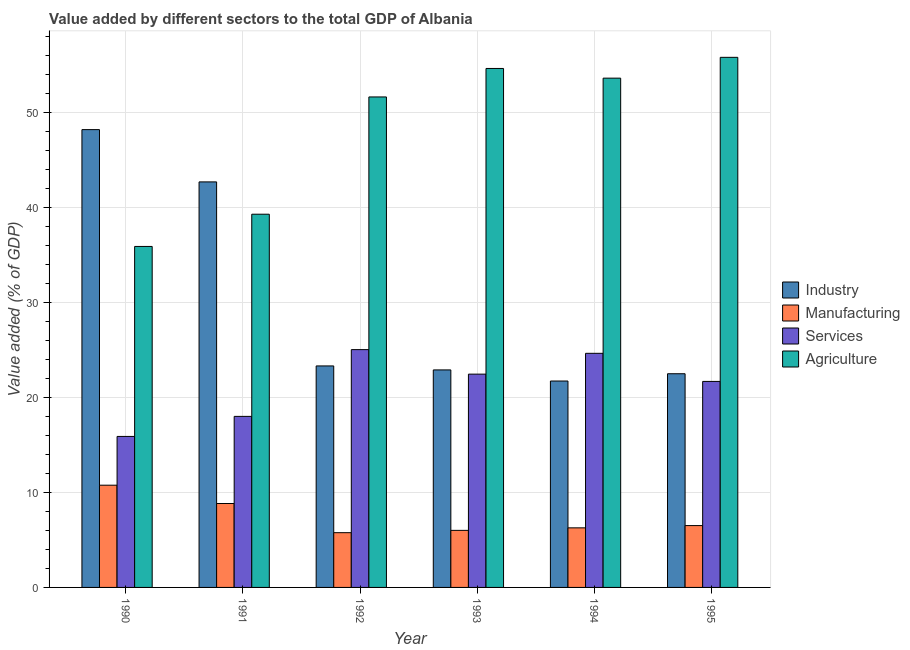Are the number of bars per tick equal to the number of legend labels?
Your answer should be very brief. Yes. How many bars are there on the 2nd tick from the left?
Keep it short and to the point. 4. In how many cases, is the number of bars for a given year not equal to the number of legend labels?
Keep it short and to the point. 0. What is the value added by industrial sector in 1993?
Provide a short and direct response. 22.9. Across all years, what is the maximum value added by services sector?
Keep it short and to the point. 25.04. Across all years, what is the minimum value added by industrial sector?
Your answer should be very brief. 21.73. In which year was the value added by agricultural sector maximum?
Provide a short and direct response. 1995. What is the total value added by services sector in the graph?
Your response must be concise. 127.74. What is the difference between the value added by industrial sector in 1990 and that in 1994?
Make the answer very short. 26.47. What is the difference between the value added by manufacturing sector in 1992 and the value added by industrial sector in 1991?
Your response must be concise. -3.07. What is the average value added by manufacturing sector per year?
Your response must be concise. 7.36. In the year 1995, what is the difference between the value added by manufacturing sector and value added by services sector?
Your answer should be very brief. 0. In how many years, is the value added by industrial sector greater than 36 %?
Ensure brevity in your answer.  2. What is the ratio of the value added by industrial sector in 1990 to that in 1993?
Your response must be concise. 2.1. Is the value added by manufacturing sector in 1991 less than that in 1993?
Your answer should be very brief. No. Is the difference between the value added by services sector in 1992 and 1993 greater than the difference between the value added by industrial sector in 1992 and 1993?
Keep it short and to the point. No. What is the difference between the highest and the second highest value added by manufacturing sector?
Give a very brief answer. 1.93. What is the difference between the highest and the lowest value added by agricultural sector?
Give a very brief answer. 19.91. Is the sum of the value added by services sector in 1990 and 1992 greater than the maximum value added by manufacturing sector across all years?
Your answer should be compact. Yes. What does the 3rd bar from the left in 1994 represents?
Provide a succinct answer. Services. What does the 4th bar from the right in 1993 represents?
Offer a very short reply. Industry. Is it the case that in every year, the sum of the value added by industrial sector and value added by manufacturing sector is greater than the value added by services sector?
Your answer should be compact. Yes. How many bars are there?
Your response must be concise. 24. How many years are there in the graph?
Keep it short and to the point. 6. What is the difference between two consecutive major ticks on the Y-axis?
Ensure brevity in your answer.  10. Does the graph contain any zero values?
Keep it short and to the point. No. Does the graph contain grids?
Offer a very short reply. Yes. Where does the legend appear in the graph?
Provide a short and direct response. Center right. How many legend labels are there?
Give a very brief answer. 4. How are the legend labels stacked?
Your answer should be compact. Vertical. What is the title of the graph?
Your answer should be very brief. Value added by different sectors to the total GDP of Albania. Does "Taxes on exports" appear as one of the legend labels in the graph?
Your answer should be compact. No. What is the label or title of the Y-axis?
Ensure brevity in your answer.  Value added (% of GDP). What is the Value added (% of GDP) in Industry in 1990?
Keep it short and to the point. 48.2. What is the Value added (% of GDP) in Manufacturing in 1990?
Provide a short and direct response. 10.76. What is the Value added (% of GDP) of Services in 1990?
Keep it short and to the point. 15.9. What is the Value added (% of GDP) of Agriculture in 1990?
Provide a succinct answer. 35.9. What is the Value added (% of GDP) of Industry in 1991?
Make the answer very short. 42.7. What is the Value added (% of GDP) of Manufacturing in 1991?
Your answer should be compact. 8.84. What is the Value added (% of GDP) of Services in 1991?
Your response must be concise. 18.01. What is the Value added (% of GDP) in Agriculture in 1991?
Ensure brevity in your answer.  39.3. What is the Value added (% of GDP) of Industry in 1992?
Your response must be concise. 23.32. What is the Value added (% of GDP) in Manufacturing in 1992?
Your answer should be very brief. 5.76. What is the Value added (% of GDP) of Services in 1992?
Your answer should be very brief. 25.04. What is the Value added (% of GDP) of Agriculture in 1992?
Your answer should be very brief. 51.64. What is the Value added (% of GDP) in Industry in 1993?
Offer a terse response. 22.9. What is the Value added (% of GDP) in Manufacturing in 1993?
Provide a succinct answer. 6.01. What is the Value added (% of GDP) in Services in 1993?
Offer a very short reply. 22.46. What is the Value added (% of GDP) in Agriculture in 1993?
Give a very brief answer. 54.64. What is the Value added (% of GDP) of Industry in 1994?
Ensure brevity in your answer.  21.73. What is the Value added (% of GDP) in Manufacturing in 1994?
Your response must be concise. 6.27. What is the Value added (% of GDP) in Services in 1994?
Offer a terse response. 24.65. What is the Value added (% of GDP) in Agriculture in 1994?
Your answer should be very brief. 53.62. What is the Value added (% of GDP) in Industry in 1995?
Give a very brief answer. 22.5. What is the Value added (% of GDP) of Manufacturing in 1995?
Offer a terse response. 6.51. What is the Value added (% of GDP) of Services in 1995?
Offer a very short reply. 21.69. What is the Value added (% of GDP) of Agriculture in 1995?
Your answer should be very brief. 55.81. Across all years, what is the maximum Value added (% of GDP) of Industry?
Offer a very short reply. 48.2. Across all years, what is the maximum Value added (% of GDP) in Manufacturing?
Your answer should be compact. 10.76. Across all years, what is the maximum Value added (% of GDP) in Services?
Your answer should be compact. 25.04. Across all years, what is the maximum Value added (% of GDP) of Agriculture?
Keep it short and to the point. 55.81. Across all years, what is the minimum Value added (% of GDP) of Industry?
Give a very brief answer. 21.73. Across all years, what is the minimum Value added (% of GDP) in Manufacturing?
Provide a short and direct response. 5.76. Across all years, what is the minimum Value added (% of GDP) of Services?
Your answer should be very brief. 15.9. Across all years, what is the minimum Value added (% of GDP) of Agriculture?
Provide a succinct answer. 35.9. What is the total Value added (% of GDP) in Industry in the graph?
Ensure brevity in your answer.  181.35. What is the total Value added (% of GDP) of Manufacturing in the graph?
Ensure brevity in your answer.  44.15. What is the total Value added (% of GDP) of Services in the graph?
Your response must be concise. 127.74. What is the total Value added (% of GDP) in Agriculture in the graph?
Offer a very short reply. 290.91. What is the difference between the Value added (% of GDP) of Industry in 1990 and that in 1991?
Your answer should be very brief. 5.5. What is the difference between the Value added (% of GDP) in Manufacturing in 1990 and that in 1991?
Make the answer very short. 1.93. What is the difference between the Value added (% of GDP) in Services in 1990 and that in 1991?
Give a very brief answer. -2.11. What is the difference between the Value added (% of GDP) in Agriculture in 1990 and that in 1991?
Keep it short and to the point. -3.39. What is the difference between the Value added (% of GDP) in Industry in 1990 and that in 1992?
Offer a very short reply. 24.88. What is the difference between the Value added (% of GDP) in Manufacturing in 1990 and that in 1992?
Give a very brief answer. 5. What is the difference between the Value added (% of GDP) of Services in 1990 and that in 1992?
Provide a short and direct response. -9.14. What is the difference between the Value added (% of GDP) of Agriculture in 1990 and that in 1992?
Keep it short and to the point. -15.74. What is the difference between the Value added (% of GDP) of Industry in 1990 and that in 1993?
Keep it short and to the point. 25.3. What is the difference between the Value added (% of GDP) in Manufacturing in 1990 and that in 1993?
Provide a succinct answer. 4.76. What is the difference between the Value added (% of GDP) in Services in 1990 and that in 1993?
Provide a short and direct response. -6.56. What is the difference between the Value added (% of GDP) of Agriculture in 1990 and that in 1993?
Your response must be concise. -18.74. What is the difference between the Value added (% of GDP) in Industry in 1990 and that in 1994?
Give a very brief answer. 26.47. What is the difference between the Value added (% of GDP) in Manufacturing in 1990 and that in 1994?
Provide a short and direct response. 4.49. What is the difference between the Value added (% of GDP) in Services in 1990 and that in 1994?
Offer a very short reply. -8.75. What is the difference between the Value added (% of GDP) of Agriculture in 1990 and that in 1994?
Give a very brief answer. -17.72. What is the difference between the Value added (% of GDP) of Industry in 1990 and that in 1995?
Ensure brevity in your answer.  25.7. What is the difference between the Value added (% of GDP) in Manufacturing in 1990 and that in 1995?
Give a very brief answer. 4.25. What is the difference between the Value added (% of GDP) of Services in 1990 and that in 1995?
Provide a short and direct response. -5.79. What is the difference between the Value added (% of GDP) in Agriculture in 1990 and that in 1995?
Provide a succinct answer. -19.91. What is the difference between the Value added (% of GDP) of Industry in 1991 and that in 1992?
Give a very brief answer. 19.38. What is the difference between the Value added (% of GDP) in Manufacturing in 1991 and that in 1992?
Your answer should be very brief. 3.07. What is the difference between the Value added (% of GDP) in Services in 1991 and that in 1992?
Give a very brief answer. -7.03. What is the difference between the Value added (% of GDP) in Agriculture in 1991 and that in 1992?
Offer a terse response. -12.35. What is the difference between the Value added (% of GDP) of Industry in 1991 and that in 1993?
Keep it short and to the point. 19.8. What is the difference between the Value added (% of GDP) in Manufacturing in 1991 and that in 1993?
Provide a short and direct response. 2.83. What is the difference between the Value added (% of GDP) in Services in 1991 and that in 1993?
Ensure brevity in your answer.  -4.45. What is the difference between the Value added (% of GDP) in Agriculture in 1991 and that in 1993?
Your answer should be compact. -15.35. What is the difference between the Value added (% of GDP) in Industry in 1991 and that in 1994?
Provide a succinct answer. 20.97. What is the difference between the Value added (% of GDP) in Manufacturing in 1991 and that in 1994?
Your answer should be compact. 2.56. What is the difference between the Value added (% of GDP) of Services in 1991 and that in 1994?
Your response must be concise. -6.64. What is the difference between the Value added (% of GDP) of Agriculture in 1991 and that in 1994?
Provide a short and direct response. -14.33. What is the difference between the Value added (% of GDP) in Industry in 1991 and that in 1995?
Your response must be concise. 20.2. What is the difference between the Value added (% of GDP) of Manufacturing in 1991 and that in 1995?
Provide a succinct answer. 2.33. What is the difference between the Value added (% of GDP) in Services in 1991 and that in 1995?
Provide a short and direct response. -3.68. What is the difference between the Value added (% of GDP) of Agriculture in 1991 and that in 1995?
Ensure brevity in your answer.  -16.52. What is the difference between the Value added (% of GDP) in Industry in 1992 and that in 1993?
Your response must be concise. 0.42. What is the difference between the Value added (% of GDP) in Manufacturing in 1992 and that in 1993?
Your response must be concise. -0.24. What is the difference between the Value added (% of GDP) in Services in 1992 and that in 1993?
Offer a terse response. 2.58. What is the difference between the Value added (% of GDP) in Agriculture in 1992 and that in 1993?
Offer a very short reply. -3. What is the difference between the Value added (% of GDP) of Industry in 1992 and that in 1994?
Offer a very short reply. 1.59. What is the difference between the Value added (% of GDP) of Manufacturing in 1992 and that in 1994?
Offer a very short reply. -0.51. What is the difference between the Value added (% of GDP) of Services in 1992 and that in 1994?
Offer a very short reply. 0.39. What is the difference between the Value added (% of GDP) of Agriculture in 1992 and that in 1994?
Make the answer very short. -1.98. What is the difference between the Value added (% of GDP) of Industry in 1992 and that in 1995?
Provide a succinct answer. 0.82. What is the difference between the Value added (% of GDP) in Manufacturing in 1992 and that in 1995?
Offer a very short reply. -0.75. What is the difference between the Value added (% of GDP) in Services in 1992 and that in 1995?
Ensure brevity in your answer.  3.35. What is the difference between the Value added (% of GDP) of Agriculture in 1992 and that in 1995?
Keep it short and to the point. -4.17. What is the difference between the Value added (% of GDP) in Industry in 1993 and that in 1994?
Ensure brevity in your answer.  1.17. What is the difference between the Value added (% of GDP) in Manufacturing in 1993 and that in 1994?
Keep it short and to the point. -0.27. What is the difference between the Value added (% of GDP) in Services in 1993 and that in 1994?
Make the answer very short. -2.19. What is the difference between the Value added (% of GDP) in Agriculture in 1993 and that in 1994?
Offer a terse response. 1.02. What is the difference between the Value added (% of GDP) in Industry in 1993 and that in 1995?
Your answer should be compact. 0.4. What is the difference between the Value added (% of GDP) in Manufacturing in 1993 and that in 1995?
Ensure brevity in your answer.  -0.5. What is the difference between the Value added (% of GDP) of Services in 1993 and that in 1995?
Give a very brief answer. 0.77. What is the difference between the Value added (% of GDP) in Agriculture in 1993 and that in 1995?
Give a very brief answer. -1.17. What is the difference between the Value added (% of GDP) of Industry in 1994 and that in 1995?
Ensure brevity in your answer.  -0.77. What is the difference between the Value added (% of GDP) in Manufacturing in 1994 and that in 1995?
Offer a very short reply. -0.24. What is the difference between the Value added (% of GDP) in Services in 1994 and that in 1995?
Your answer should be very brief. 2.96. What is the difference between the Value added (% of GDP) in Agriculture in 1994 and that in 1995?
Your answer should be very brief. -2.19. What is the difference between the Value added (% of GDP) in Industry in 1990 and the Value added (% of GDP) in Manufacturing in 1991?
Your answer should be very brief. 39.36. What is the difference between the Value added (% of GDP) in Industry in 1990 and the Value added (% of GDP) in Services in 1991?
Offer a terse response. 30.19. What is the difference between the Value added (% of GDP) of Industry in 1990 and the Value added (% of GDP) of Agriculture in 1991?
Keep it short and to the point. 8.91. What is the difference between the Value added (% of GDP) in Manufacturing in 1990 and the Value added (% of GDP) in Services in 1991?
Provide a short and direct response. -7.24. What is the difference between the Value added (% of GDP) of Manufacturing in 1990 and the Value added (% of GDP) of Agriculture in 1991?
Your answer should be very brief. -28.53. What is the difference between the Value added (% of GDP) of Services in 1990 and the Value added (% of GDP) of Agriculture in 1991?
Provide a short and direct response. -23.4. What is the difference between the Value added (% of GDP) of Industry in 1990 and the Value added (% of GDP) of Manufacturing in 1992?
Give a very brief answer. 42.44. What is the difference between the Value added (% of GDP) in Industry in 1990 and the Value added (% of GDP) in Services in 1992?
Make the answer very short. 23.16. What is the difference between the Value added (% of GDP) in Industry in 1990 and the Value added (% of GDP) in Agriculture in 1992?
Offer a very short reply. -3.44. What is the difference between the Value added (% of GDP) in Manufacturing in 1990 and the Value added (% of GDP) in Services in 1992?
Keep it short and to the point. -14.27. What is the difference between the Value added (% of GDP) in Manufacturing in 1990 and the Value added (% of GDP) in Agriculture in 1992?
Give a very brief answer. -40.88. What is the difference between the Value added (% of GDP) in Services in 1990 and the Value added (% of GDP) in Agriculture in 1992?
Your response must be concise. -35.74. What is the difference between the Value added (% of GDP) of Industry in 1990 and the Value added (% of GDP) of Manufacturing in 1993?
Ensure brevity in your answer.  42.19. What is the difference between the Value added (% of GDP) of Industry in 1990 and the Value added (% of GDP) of Services in 1993?
Offer a terse response. 25.74. What is the difference between the Value added (% of GDP) in Industry in 1990 and the Value added (% of GDP) in Agriculture in 1993?
Ensure brevity in your answer.  -6.44. What is the difference between the Value added (% of GDP) of Manufacturing in 1990 and the Value added (% of GDP) of Services in 1993?
Offer a terse response. -11.69. What is the difference between the Value added (% of GDP) in Manufacturing in 1990 and the Value added (% of GDP) in Agriculture in 1993?
Your answer should be very brief. -43.88. What is the difference between the Value added (% of GDP) in Services in 1990 and the Value added (% of GDP) in Agriculture in 1993?
Offer a very short reply. -38.74. What is the difference between the Value added (% of GDP) of Industry in 1990 and the Value added (% of GDP) of Manufacturing in 1994?
Provide a short and direct response. 41.93. What is the difference between the Value added (% of GDP) of Industry in 1990 and the Value added (% of GDP) of Services in 1994?
Offer a terse response. 23.55. What is the difference between the Value added (% of GDP) of Industry in 1990 and the Value added (% of GDP) of Agriculture in 1994?
Your answer should be compact. -5.42. What is the difference between the Value added (% of GDP) in Manufacturing in 1990 and the Value added (% of GDP) in Services in 1994?
Your answer should be compact. -13.88. What is the difference between the Value added (% of GDP) of Manufacturing in 1990 and the Value added (% of GDP) of Agriculture in 1994?
Give a very brief answer. -42.86. What is the difference between the Value added (% of GDP) of Services in 1990 and the Value added (% of GDP) of Agriculture in 1994?
Offer a very short reply. -37.72. What is the difference between the Value added (% of GDP) in Industry in 1990 and the Value added (% of GDP) in Manufacturing in 1995?
Ensure brevity in your answer.  41.69. What is the difference between the Value added (% of GDP) in Industry in 1990 and the Value added (% of GDP) in Services in 1995?
Give a very brief answer. 26.51. What is the difference between the Value added (% of GDP) in Industry in 1990 and the Value added (% of GDP) in Agriculture in 1995?
Make the answer very short. -7.61. What is the difference between the Value added (% of GDP) in Manufacturing in 1990 and the Value added (% of GDP) in Services in 1995?
Make the answer very short. -10.93. What is the difference between the Value added (% of GDP) in Manufacturing in 1990 and the Value added (% of GDP) in Agriculture in 1995?
Keep it short and to the point. -45.05. What is the difference between the Value added (% of GDP) of Services in 1990 and the Value added (% of GDP) of Agriculture in 1995?
Your answer should be compact. -39.91. What is the difference between the Value added (% of GDP) of Industry in 1991 and the Value added (% of GDP) of Manufacturing in 1992?
Offer a very short reply. 36.93. What is the difference between the Value added (% of GDP) of Industry in 1991 and the Value added (% of GDP) of Services in 1992?
Your answer should be very brief. 17.66. What is the difference between the Value added (% of GDP) in Industry in 1991 and the Value added (% of GDP) in Agriculture in 1992?
Provide a short and direct response. -8.95. What is the difference between the Value added (% of GDP) in Manufacturing in 1991 and the Value added (% of GDP) in Services in 1992?
Give a very brief answer. -16.2. What is the difference between the Value added (% of GDP) in Manufacturing in 1991 and the Value added (% of GDP) in Agriculture in 1992?
Your answer should be very brief. -42.81. What is the difference between the Value added (% of GDP) in Services in 1991 and the Value added (% of GDP) in Agriculture in 1992?
Provide a succinct answer. -33.63. What is the difference between the Value added (% of GDP) in Industry in 1991 and the Value added (% of GDP) in Manufacturing in 1993?
Your response must be concise. 36.69. What is the difference between the Value added (% of GDP) in Industry in 1991 and the Value added (% of GDP) in Services in 1993?
Give a very brief answer. 20.24. What is the difference between the Value added (% of GDP) of Industry in 1991 and the Value added (% of GDP) of Agriculture in 1993?
Your response must be concise. -11.94. What is the difference between the Value added (% of GDP) in Manufacturing in 1991 and the Value added (% of GDP) in Services in 1993?
Ensure brevity in your answer.  -13.62. What is the difference between the Value added (% of GDP) of Manufacturing in 1991 and the Value added (% of GDP) of Agriculture in 1993?
Keep it short and to the point. -45.81. What is the difference between the Value added (% of GDP) in Services in 1991 and the Value added (% of GDP) in Agriculture in 1993?
Give a very brief answer. -36.63. What is the difference between the Value added (% of GDP) of Industry in 1991 and the Value added (% of GDP) of Manufacturing in 1994?
Give a very brief answer. 36.42. What is the difference between the Value added (% of GDP) of Industry in 1991 and the Value added (% of GDP) of Services in 1994?
Offer a very short reply. 18.05. What is the difference between the Value added (% of GDP) of Industry in 1991 and the Value added (% of GDP) of Agriculture in 1994?
Give a very brief answer. -10.92. What is the difference between the Value added (% of GDP) of Manufacturing in 1991 and the Value added (% of GDP) of Services in 1994?
Make the answer very short. -15.81. What is the difference between the Value added (% of GDP) of Manufacturing in 1991 and the Value added (% of GDP) of Agriculture in 1994?
Offer a terse response. -44.79. What is the difference between the Value added (% of GDP) in Services in 1991 and the Value added (% of GDP) in Agriculture in 1994?
Offer a terse response. -35.61. What is the difference between the Value added (% of GDP) of Industry in 1991 and the Value added (% of GDP) of Manufacturing in 1995?
Give a very brief answer. 36.19. What is the difference between the Value added (% of GDP) in Industry in 1991 and the Value added (% of GDP) in Services in 1995?
Provide a short and direct response. 21.01. What is the difference between the Value added (% of GDP) of Industry in 1991 and the Value added (% of GDP) of Agriculture in 1995?
Ensure brevity in your answer.  -13.12. What is the difference between the Value added (% of GDP) of Manufacturing in 1991 and the Value added (% of GDP) of Services in 1995?
Your answer should be compact. -12.85. What is the difference between the Value added (% of GDP) of Manufacturing in 1991 and the Value added (% of GDP) of Agriculture in 1995?
Offer a very short reply. -46.98. What is the difference between the Value added (% of GDP) of Services in 1991 and the Value added (% of GDP) of Agriculture in 1995?
Your response must be concise. -37.8. What is the difference between the Value added (% of GDP) of Industry in 1992 and the Value added (% of GDP) of Manufacturing in 1993?
Your response must be concise. 17.31. What is the difference between the Value added (% of GDP) in Industry in 1992 and the Value added (% of GDP) in Services in 1993?
Offer a terse response. 0.86. What is the difference between the Value added (% of GDP) in Industry in 1992 and the Value added (% of GDP) in Agriculture in 1993?
Your response must be concise. -31.32. What is the difference between the Value added (% of GDP) in Manufacturing in 1992 and the Value added (% of GDP) in Services in 1993?
Your response must be concise. -16.69. What is the difference between the Value added (% of GDP) in Manufacturing in 1992 and the Value added (% of GDP) in Agriculture in 1993?
Your answer should be very brief. -48.88. What is the difference between the Value added (% of GDP) in Services in 1992 and the Value added (% of GDP) in Agriculture in 1993?
Make the answer very short. -29.6. What is the difference between the Value added (% of GDP) of Industry in 1992 and the Value added (% of GDP) of Manufacturing in 1994?
Your response must be concise. 17.05. What is the difference between the Value added (% of GDP) in Industry in 1992 and the Value added (% of GDP) in Services in 1994?
Your response must be concise. -1.33. What is the difference between the Value added (% of GDP) of Industry in 1992 and the Value added (% of GDP) of Agriculture in 1994?
Your response must be concise. -30.3. What is the difference between the Value added (% of GDP) in Manufacturing in 1992 and the Value added (% of GDP) in Services in 1994?
Provide a short and direct response. -18.88. What is the difference between the Value added (% of GDP) of Manufacturing in 1992 and the Value added (% of GDP) of Agriculture in 1994?
Provide a succinct answer. -47.86. What is the difference between the Value added (% of GDP) of Services in 1992 and the Value added (% of GDP) of Agriculture in 1994?
Make the answer very short. -28.58. What is the difference between the Value added (% of GDP) in Industry in 1992 and the Value added (% of GDP) in Manufacturing in 1995?
Keep it short and to the point. 16.81. What is the difference between the Value added (% of GDP) of Industry in 1992 and the Value added (% of GDP) of Services in 1995?
Ensure brevity in your answer.  1.63. What is the difference between the Value added (% of GDP) in Industry in 1992 and the Value added (% of GDP) in Agriculture in 1995?
Your response must be concise. -32.49. What is the difference between the Value added (% of GDP) in Manufacturing in 1992 and the Value added (% of GDP) in Services in 1995?
Ensure brevity in your answer.  -15.93. What is the difference between the Value added (% of GDP) of Manufacturing in 1992 and the Value added (% of GDP) of Agriculture in 1995?
Provide a short and direct response. -50.05. What is the difference between the Value added (% of GDP) in Services in 1992 and the Value added (% of GDP) in Agriculture in 1995?
Give a very brief answer. -30.77. What is the difference between the Value added (% of GDP) in Industry in 1993 and the Value added (% of GDP) in Manufacturing in 1994?
Your answer should be compact. 16.63. What is the difference between the Value added (% of GDP) of Industry in 1993 and the Value added (% of GDP) of Services in 1994?
Keep it short and to the point. -1.75. What is the difference between the Value added (% of GDP) of Industry in 1993 and the Value added (% of GDP) of Agriculture in 1994?
Keep it short and to the point. -30.72. What is the difference between the Value added (% of GDP) of Manufacturing in 1993 and the Value added (% of GDP) of Services in 1994?
Offer a very short reply. -18.64. What is the difference between the Value added (% of GDP) of Manufacturing in 1993 and the Value added (% of GDP) of Agriculture in 1994?
Make the answer very short. -47.61. What is the difference between the Value added (% of GDP) in Services in 1993 and the Value added (% of GDP) in Agriculture in 1994?
Provide a short and direct response. -31.16. What is the difference between the Value added (% of GDP) of Industry in 1993 and the Value added (% of GDP) of Manufacturing in 1995?
Keep it short and to the point. 16.39. What is the difference between the Value added (% of GDP) in Industry in 1993 and the Value added (% of GDP) in Services in 1995?
Your answer should be compact. 1.21. What is the difference between the Value added (% of GDP) in Industry in 1993 and the Value added (% of GDP) in Agriculture in 1995?
Offer a very short reply. -32.91. What is the difference between the Value added (% of GDP) of Manufacturing in 1993 and the Value added (% of GDP) of Services in 1995?
Offer a terse response. -15.68. What is the difference between the Value added (% of GDP) in Manufacturing in 1993 and the Value added (% of GDP) in Agriculture in 1995?
Offer a very short reply. -49.81. What is the difference between the Value added (% of GDP) of Services in 1993 and the Value added (% of GDP) of Agriculture in 1995?
Keep it short and to the point. -33.35. What is the difference between the Value added (% of GDP) in Industry in 1994 and the Value added (% of GDP) in Manufacturing in 1995?
Keep it short and to the point. 15.22. What is the difference between the Value added (% of GDP) in Industry in 1994 and the Value added (% of GDP) in Services in 1995?
Ensure brevity in your answer.  0.04. What is the difference between the Value added (% of GDP) in Industry in 1994 and the Value added (% of GDP) in Agriculture in 1995?
Ensure brevity in your answer.  -34.08. What is the difference between the Value added (% of GDP) in Manufacturing in 1994 and the Value added (% of GDP) in Services in 1995?
Your response must be concise. -15.42. What is the difference between the Value added (% of GDP) in Manufacturing in 1994 and the Value added (% of GDP) in Agriculture in 1995?
Ensure brevity in your answer.  -49.54. What is the difference between the Value added (% of GDP) of Services in 1994 and the Value added (% of GDP) of Agriculture in 1995?
Provide a short and direct response. -31.16. What is the average Value added (% of GDP) in Industry per year?
Give a very brief answer. 30.22. What is the average Value added (% of GDP) of Manufacturing per year?
Offer a very short reply. 7.36. What is the average Value added (% of GDP) in Services per year?
Give a very brief answer. 21.29. What is the average Value added (% of GDP) in Agriculture per year?
Make the answer very short. 48.49. In the year 1990, what is the difference between the Value added (% of GDP) of Industry and Value added (% of GDP) of Manufacturing?
Ensure brevity in your answer.  37.44. In the year 1990, what is the difference between the Value added (% of GDP) of Industry and Value added (% of GDP) of Services?
Your answer should be compact. 32.3. In the year 1990, what is the difference between the Value added (% of GDP) in Manufacturing and Value added (% of GDP) in Services?
Your answer should be very brief. -5.13. In the year 1990, what is the difference between the Value added (% of GDP) of Manufacturing and Value added (% of GDP) of Agriculture?
Your response must be concise. -25.14. In the year 1990, what is the difference between the Value added (% of GDP) of Services and Value added (% of GDP) of Agriculture?
Give a very brief answer. -20. In the year 1991, what is the difference between the Value added (% of GDP) in Industry and Value added (% of GDP) in Manufacturing?
Your answer should be compact. 33.86. In the year 1991, what is the difference between the Value added (% of GDP) of Industry and Value added (% of GDP) of Services?
Provide a succinct answer. 24.69. In the year 1991, what is the difference between the Value added (% of GDP) of Industry and Value added (% of GDP) of Agriculture?
Your answer should be compact. 3.4. In the year 1991, what is the difference between the Value added (% of GDP) in Manufacturing and Value added (% of GDP) in Services?
Keep it short and to the point. -9.17. In the year 1991, what is the difference between the Value added (% of GDP) in Manufacturing and Value added (% of GDP) in Agriculture?
Offer a very short reply. -30.46. In the year 1991, what is the difference between the Value added (% of GDP) in Services and Value added (% of GDP) in Agriculture?
Provide a short and direct response. -21.29. In the year 1992, what is the difference between the Value added (% of GDP) in Industry and Value added (% of GDP) in Manufacturing?
Keep it short and to the point. 17.56. In the year 1992, what is the difference between the Value added (% of GDP) in Industry and Value added (% of GDP) in Services?
Ensure brevity in your answer.  -1.72. In the year 1992, what is the difference between the Value added (% of GDP) of Industry and Value added (% of GDP) of Agriculture?
Provide a short and direct response. -28.32. In the year 1992, what is the difference between the Value added (% of GDP) of Manufacturing and Value added (% of GDP) of Services?
Provide a succinct answer. -19.27. In the year 1992, what is the difference between the Value added (% of GDP) in Manufacturing and Value added (% of GDP) in Agriculture?
Your answer should be compact. -45.88. In the year 1992, what is the difference between the Value added (% of GDP) in Services and Value added (% of GDP) in Agriculture?
Ensure brevity in your answer.  -26.6. In the year 1993, what is the difference between the Value added (% of GDP) in Industry and Value added (% of GDP) in Manufacturing?
Your answer should be very brief. 16.89. In the year 1993, what is the difference between the Value added (% of GDP) in Industry and Value added (% of GDP) in Services?
Your answer should be compact. 0.44. In the year 1993, what is the difference between the Value added (% of GDP) of Industry and Value added (% of GDP) of Agriculture?
Provide a short and direct response. -31.74. In the year 1993, what is the difference between the Value added (% of GDP) in Manufacturing and Value added (% of GDP) in Services?
Offer a terse response. -16.45. In the year 1993, what is the difference between the Value added (% of GDP) of Manufacturing and Value added (% of GDP) of Agriculture?
Your answer should be compact. -48.63. In the year 1993, what is the difference between the Value added (% of GDP) in Services and Value added (% of GDP) in Agriculture?
Offer a very short reply. -32.18. In the year 1994, what is the difference between the Value added (% of GDP) in Industry and Value added (% of GDP) in Manufacturing?
Your answer should be compact. 15.46. In the year 1994, what is the difference between the Value added (% of GDP) of Industry and Value added (% of GDP) of Services?
Provide a short and direct response. -2.92. In the year 1994, what is the difference between the Value added (% of GDP) in Industry and Value added (% of GDP) in Agriculture?
Offer a very short reply. -31.89. In the year 1994, what is the difference between the Value added (% of GDP) in Manufacturing and Value added (% of GDP) in Services?
Your response must be concise. -18.38. In the year 1994, what is the difference between the Value added (% of GDP) in Manufacturing and Value added (% of GDP) in Agriculture?
Offer a terse response. -47.35. In the year 1994, what is the difference between the Value added (% of GDP) of Services and Value added (% of GDP) of Agriculture?
Keep it short and to the point. -28.97. In the year 1995, what is the difference between the Value added (% of GDP) of Industry and Value added (% of GDP) of Manufacturing?
Make the answer very short. 15.99. In the year 1995, what is the difference between the Value added (% of GDP) in Industry and Value added (% of GDP) in Services?
Give a very brief answer. 0.81. In the year 1995, what is the difference between the Value added (% of GDP) in Industry and Value added (% of GDP) in Agriculture?
Offer a terse response. -33.31. In the year 1995, what is the difference between the Value added (% of GDP) of Manufacturing and Value added (% of GDP) of Services?
Offer a very short reply. -15.18. In the year 1995, what is the difference between the Value added (% of GDP) in Manufacturing and Value added (% of GDP) in Agriculture?
Your answer should be very brief. -49.3. In the year 1995, what is the difference between the Value added (% of GDP) in Services and Value added (% of GDP) in Agriculture?
Make the answer very short. -34.12. What is the ratio of the Value added (% of GDP) of Industry in 1990 to that in 1991?
Offer a very short reply. 1.13. What is the ratio of the Value added (% of GDP) of Manufacturing in 1990 to that in 1991?
Your response must be concise. 1.22. What is the ratio of the Value added (% of GDP) of Services in 1990 to that in 1991?
Your response must be concise. 0.88. What is the ratio of the Value added (% of GDP) in Agriculture in 1990 to that in 1991?
Provide a short and direct response. 0.91. What is the ratio of the Value added (% of GDP) in Industry in 1990 to that in 1992?
Keep it short and to the point. 2.07. What is the ratio of the Value added (% of GDP) in Manufacturing in 1990 to that in 1992?
Your answer should be very brief. 1.87. What is the ratio of the Value added (% of GDP) of Services in 1990 to that in 1992?
Offer a terse response. 0.64. What is the ratio of the Value added (% of GDP) in Agriculture in 1990 to that in 1992?
Offer a very short reply. 0.7. What is the ratio of the Value added (% of GDP) in Industry in 1990 to that in 1993?
Ensure brevity in your answer.  2.1. What is the ratio of the Value added (% of GDP) of Manufacturing in 1990 to that in 1993?
Provide a short and direct response. 1.79. What is the ratio of the Value added (% of GDP) of Services in 1990 to that in 1993?
Ensure brevity in your answer.  0.71. What is the ratio of the Value added (% of GDP) in Agriculture in 1990 to that in 1993?
Provide a short and direct response. 0.66. What is the ratio of the Value added (% of GDP) in Industry in 1990 to that in 1994?
Your response must be concise. 2.22. What is the ratio of the Value added (% of GDP) of Manufacturing in 1990 to that in 1994?
Give a very brief answer. 1.72. What is the ratio of the Value added (% of GDP) in Services in 1990 to that in 1994?
Your answer should be very brief. 0.65. What is the ratio of the Value added (% of GDP) of Agriculture in 1990 to that in 1994?
Offer a very short reply. 0.67. What is the ratio of the Value added (% of GDP) in Industry in 1990 to that in 1995?
Offer a terse response. 2.14. What is the ratio of the Value added (% of GDP) in Manufacturing in 1990 to that in 1995?
Keep it short and to the point. 1.65. What is the ratio of the Value added (% of GDP) in Services in 1990 to that in 1995?
Your response must be concise. 0.73. What is the ratio of the Value added (% of GDP) of Agriculture in 1990 to that in 1995?
Offer a very short reply. 0.64. What is the ratio of the Value added (% of GDP) of Industry in 1991 to that in 1992?
Make the answer very short. 1.83. What is the ratio of the Value added (% of GDP) of Manufacturing in 1991 to that in 1992?
Keep it short and to the point. 1.53. What is the ratio of the Value added (% of GDP) in Services in 1991 to that in 1992?
Provide a succinct answer. 0.72. What is the ratio of the Value added (% of GDP) in Agriculture in 1991 to that in 1992?
Make the answer very short. 0.76. What is the ratio of the Value added (% of GDP) of Industry in 1991 to that in 1993?
Your response must be concise. 1.86. What is the ratio of the Value added (% of GDP) in Manufacturing in 1991 to that in 1993?
Provide a short and direct response. 1.47. What is the ratio of the Value added (% of GDP) in Services in 1991 to that in 1993?
Your answer should be very brief. 0.8. What is the ratio of the Value added (% of GDP) in Agriculture in 1991 to that in 1993?
Offer a terse response. 0.72. What is the ratio of the Value added (% of GDP) in Industry in 1991 to that in 1994?
Your answer should be compact. 1.96. What is the ratio of the Value added (% of GDP) of Manufacturing in 1991 to that in 1994?
Give a very brief answer. 1.41. What is the ratio of the Value added (% of GDP) of Services in 1991 to that in 1994?
Offer a terse response. 0.73. What is the ratio of the Value added (% of GDP) in Agriculture in 1991 to that in 1994?
Ensure brevity in your answer.  0.73. What is the ratio of the Value added (% of GDP) in Industry in 1991 to that in 1995?
Offer a very short reply. 1.9. What is the ratio of the Value added (% of GDP) in Manufacturing in 1991 to that in 1995?
Offer a terse response. 1.36. What is the ratio of the Value added (% of GDP) in Services in 1991 to that in 1995?
Offer a terse response. 0.83. What is the ratio of the Value added (% of GDP) of Agriculture in 1991 to that in 1995?
Ensure brevity in your answer.  0.7. What is the ratio of the Value added (% of GDP) in Industry in 1992 to that in 1993?
Offer a very short reply. 1.02. What is the ratio of the Value added (% of GDP) of Manufacturing in 1992 to that in 1993?
Your response must be concise. 0.96. What is the ratio of the Value added (% of GDP) in Services in 1992 to that in 1993?
Your answer should be very brief. 1.11. What is the ratio of the Value added (% of GDP) of Agriculture in 1992 to that in 1993?
Give a very brief answer. 0.95. What is the ratio of the Value added (% of GDP) of Industry in 1992 to that in 1994?
Make the answer very short. 1.07. What is the ratio of the Value added (% of GDP) in Manufacturing in 1992 to that in 1994?
Make the answer very short. 0.92. What is the ratio of the Value added (% of GDP) of Services in 1992 to that in 1994?
Provide a succinct answer. 1.02. What is the ratio of the Value added (% of GDP) of Agriculture in 1992 to that in 1994?
Offer a terse response. 0.96. What is the ratio of the Value added (% of GDP) in Industry in 1992 to that in 1995?
Make the answer very short. 1.04. What is the ratio of the Value added (% of GDP) of Manufacturing in 1992 to that in 1995?
Provide a succinct answer. 0.89. What is the ratio of the Value added (% of GDP) of Services in 1992 to that in 1995?
Your answer should be compact. 1.15. What is the ratio of the Value added (% of GDP) in Agriculture in 1992 to that in 1995?
Give a very brief answer. 0.93. What is the ratio of the Value added (% of GDP) of Industry in 1993 to that in 1994?
Make the answer very short. 1.05. What is the ratio of the Value added (% of GDP) of Manufacturing in 1993 to that in 1994?
Give a very brief answer. 0.96. What is the ratio of the Value added (% of GDP) in Services in 1993 to that in 1994?
Make the answer very short. 0.91. What is the ratio of the Value added (% of GDP) in Agriculture in 1993 to that in 1994?
Provide a succinct answer. 1.02. What is the ratio of the Value added (% of GDP) in Industry in 1993 to that in 1995?
Your answer should be very brief. 1.02. What is the ratio of the Value added (% of GDP) of Manufacturing in 1993 to that in 1995?
Offer a terse response. 0.92. What is the ratio of the Value added (% of GDP) of Services in 1993 to that in 1995?
Your answer should be very brief. 1.04. What is the ratio of the Value added (% of GDP) in Agriculture in 1993 to that in 1995?
Your answer should be very brief. 0.98. What is the ratio of the Value added (% of GDP) in Industry in 1994 to that in 1995?
Your response must be concise. 0.97. What is the ratio of the Value added (% of GDP) in Manufacturing in 1994 to that in 1995?
Your answer should be compact. 0.96. What is the ratio of the Value added (% of GDP) of Services in 1994 to that in 1995?
Your answer should be very brief. 1.14. What is the ratio of the Value added (% of GDP) of Agriculture in 1994 to that in 1995?
Give a very brief answer. 0.96. What is the difference between the highest and the second highest Value added (% of GDP) of Industry?
Make the answer very short. 5.5. What is the difference between the highest and the second highest Value added (% of GDP) in Manufacturing?
Your answer should be very brief. 1.93. What is the difference between the highest and the second highest Value added (% of GDP) in Services?
Offer a terse response. 0.39. What is the difference between the highest and the second highest Value added (% of GDP) of Agriculture?
Your answer should be very brief. 1.17. What is the difference between the highest and the lowest Value added (% of GDP) in Industry?
Make the answer very short. 26.47. What is the difference between the highest and the lowest Value added (% of GDP) of Manufacturing?
Your response must be concise. 5. What is the difference between the highest and the lowest Value added (% of GDP) in Services?
Your answer should be compact. 9.14. What is the difference between the highest and the lowest Value added (% of GDP) of Agriculture?
Provide a succinct answer. 19.91. 